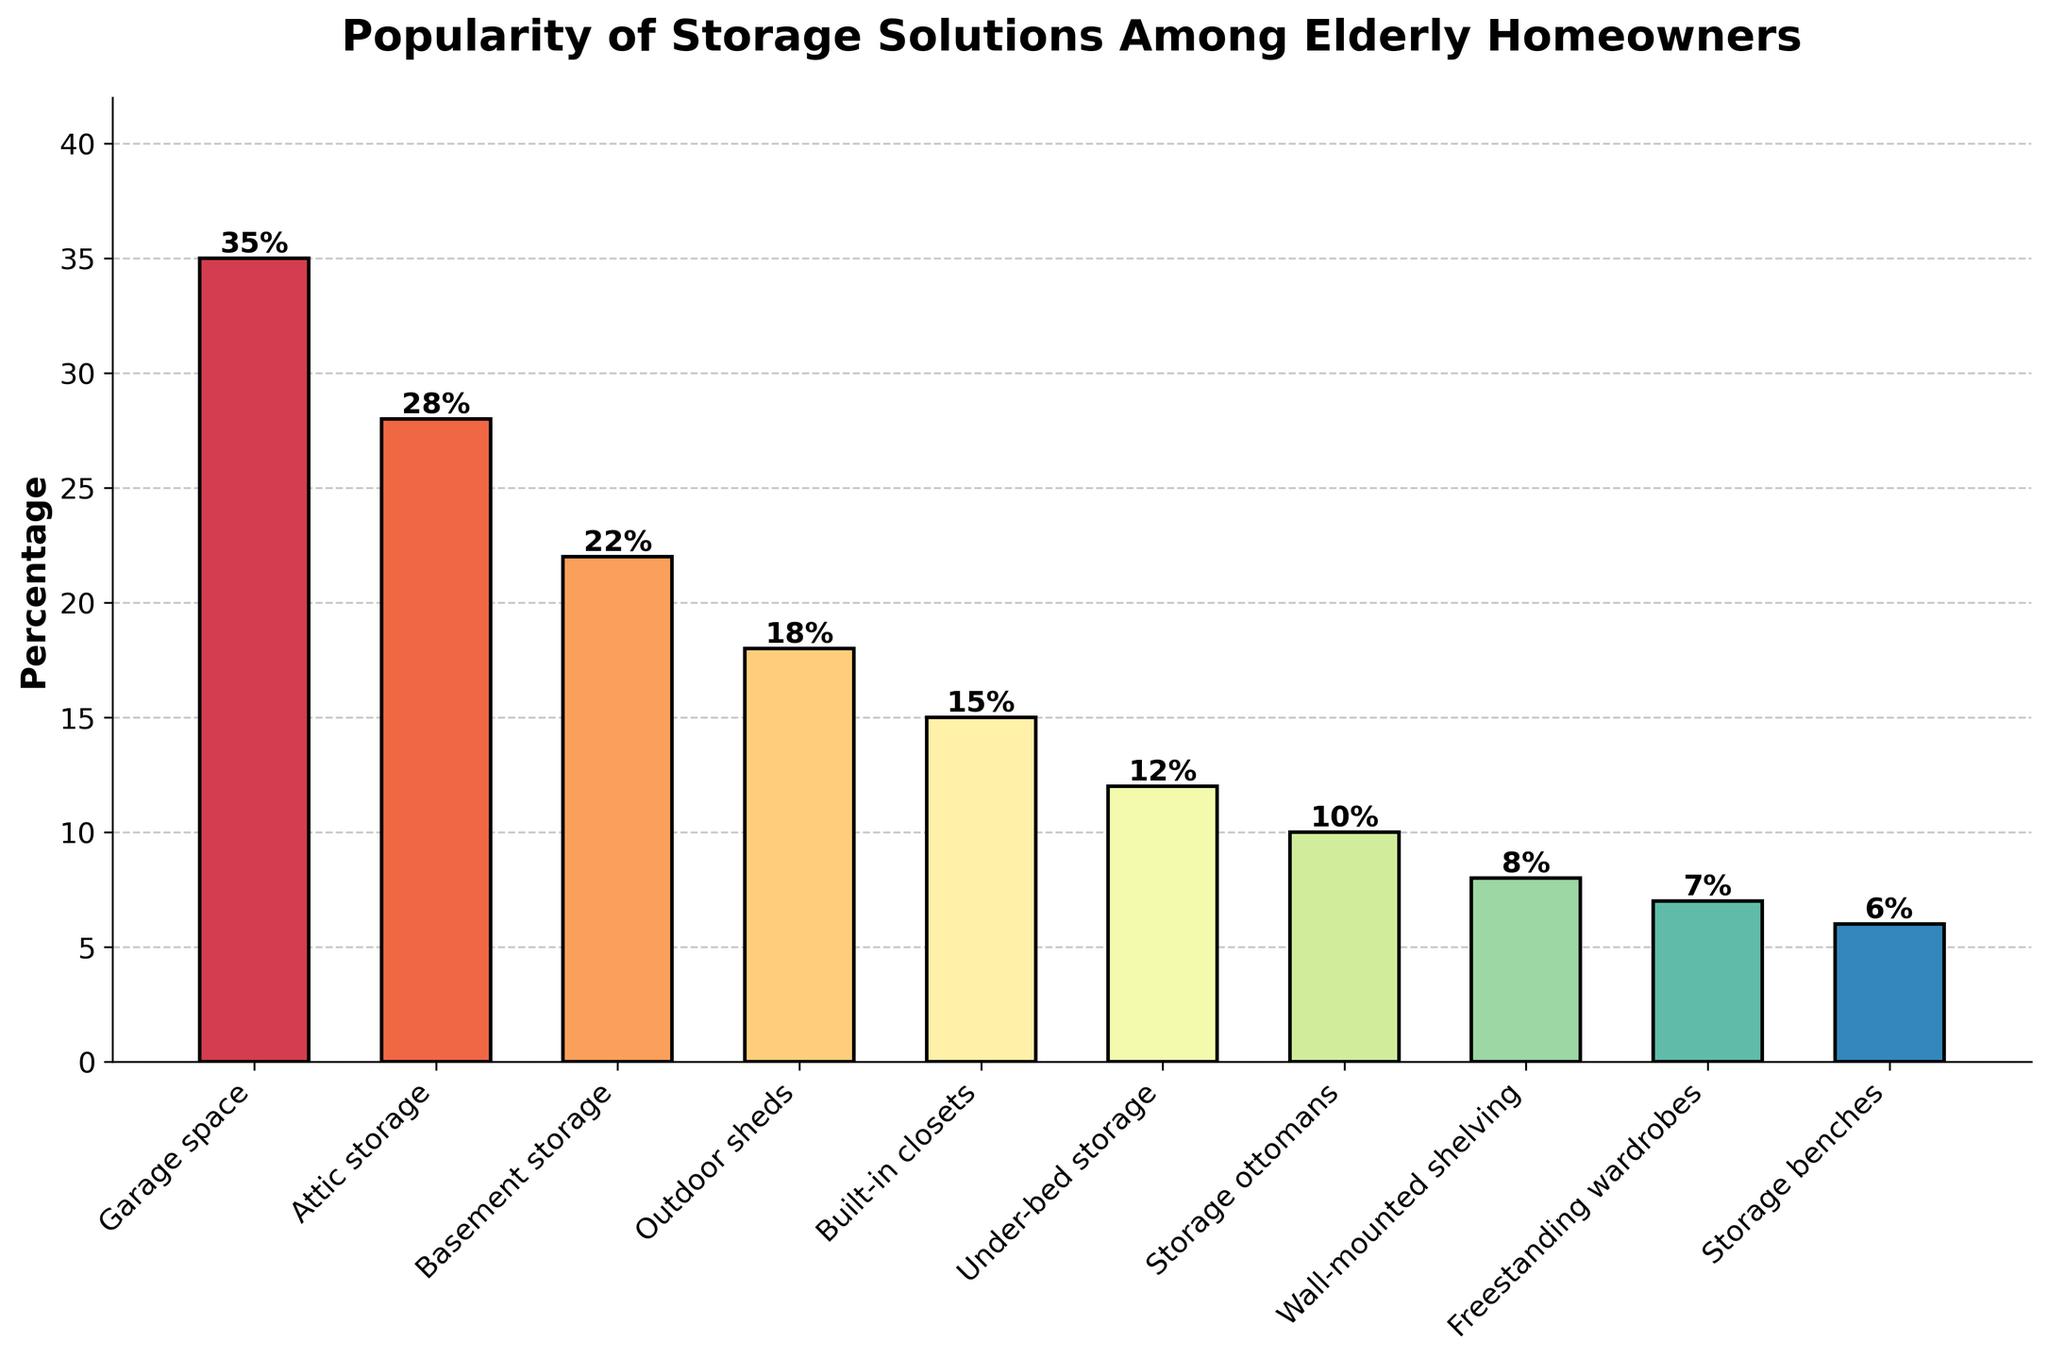Which storage solution is the most popular among elderly homeowners? The highest bar in the chart represents the most popular storage solution. By looking at the bar's height, we notice that garage space is the tallest with 35%.
Answer: Garage space How many storage solutions have a popularity of 20% or higher? By scanning the bars, we can identify the ones exceeding 20%: Garage space (35%), Attic storage (28%), and Basement storage (22%). That's 3 solutions.
Answer: 3 Which storage solution is less popular: outdoor sheds or freestanding wardrobes? Comparing the heights of the bars for outdoor sheds (18%) and freestanding wardrobes (7%), the latter is shorter, indicating less popularity.
Answer: Freestanding wardrobes What is the combined popularity percentage of built-in closets and under-bed storage? We need to sum the percentages of both solutions: Built-in closets (15%) + Under-bed storage (12%) = 27%.
Answer: 27% How does the popularity of wall-mounted shelving compare to storage ottomans? By comparing the two bars, wall-mounted shelving has 8% while storage ottomans have 10%. Wall-mounted shelving is less popular.
Answer: Less popular Which storage solutions have a popularity of 10% or below? Checking the bars, we see these solutions: Storage ottomans (10%), Wall-mounted shelving (8%), Freestanding wardrobes (7%), and Storage benches (6%).
Answer: Storage ottomans, Wall-mounted shelving, Freestanding wardrobes, Storage benches What is the difference in popularity between the most and least popular storage solutions? Subtract the percentage of the least popular solution (Storage benches, 6%) from the most popular (Garage space, 35%): 35% - 6% = 29%.
Answer: 29% What is the average popularity percentage of the top three storage solutions? Sum the percentages of the top three solutions (Garage space 35%, Attic storage 28%, Basement storage 22%) and divide by 3: (35 + 28 + 22) / 3 = 28.33%.
Answer: 28.33% Which solution is more popular: under-bed storage or built-in closets? By comparing their bars, built-in closets (15%) are more popular than under-bed storage (12%).
Answer: Built-in closets Is the popularity of outdoor sheds higher than half of garage space’s popularity? Compare the percentage of outdoor sheds (18%) to half of garage space's popularity (35% / 2 = 17.5%). Since 18% > 17.5%, outdoor sheds are indeed more popular.
Answer: Yes 